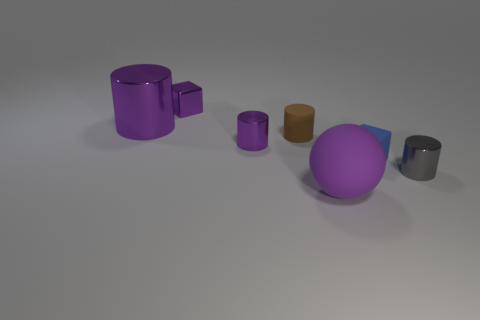Are there the same number of big purple objects that are in front of the big shiny cylinder and brown objects?
Offer a very short reply. Yes. What number of purple shiny things are the same shape as the blue matte object?
Make the answer very short. 1. Is the small blue object the same shape as the purple rubber object?
Offer a terse response. No. What number of things are either tiny purple metallic objects that are behind the tiny brown object or large green shiny cubes?
Your answer should be compact. 1. What shape is the tiny purple thing behind the small metallic cylinder that is behind the tiny object that is in front of the blue rubber block?
Offer a terse response. Cube. What shape is the blue thing that is the same material as the small brown cylinder?
Offer a terse response. Cube. What is the size of the ball?
Offer a very short reply. Large. Is the size of the shiny cube the same as the brown object?
Give a very brief answer. Yes. What number of objects are tiny purple things that are in front of the big shiny thing or things that are left of the gray metallic cylinder?
Your answer should be compact. 6. How many gray objects are on the left side of the large purple thing that is to the left of the purple thing that is in front of the gray cylinder?
Offer a very short reply. 0. 